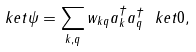<formula> <loc_0><loc_0><loc_500><loc_500>\ k e t { \psi } = \sum _ { k , q } w _ { k q } a _ { k } ^ { \dagger } a _ { q } ^ { \dagger } \ k e t { 0 } ,</formula> 